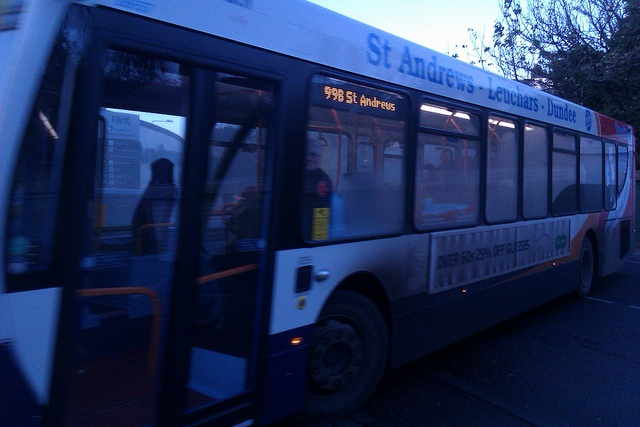Describe the objects in this image and their specific colors. I can see bus in black, navy, gray, and blue tones, people in gray, black, navy, darkblue, and purple tones, and people in gray, navy, darkblue, and purple tones in this image. 